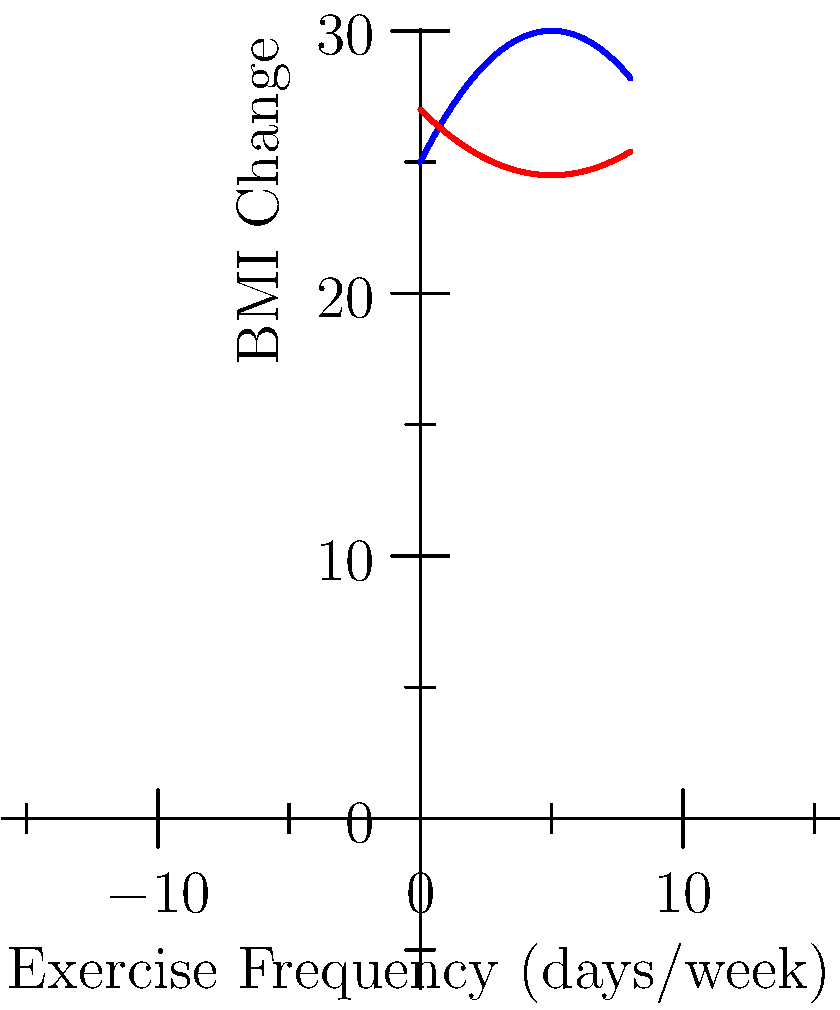The graph shows the relationship between exercise frequency and BMI change for two groups in a weight management study. Group A is represented by the blue curve (concave down) and Group B by the red curve (concave up). At what exercise frequency (in days per week) do both groups experience the same BMI change? Round your answer to one decimal place. To find the point where both groups experience the same BMI change, we need to find the intersection of the two polynomial functions:

1) Let's define the functions:
   Group A: $f(x) = -0.2x^2 + 2x + 25$
   Group B: $g(x) = 0.1x^2 - x + 27$

2) At the intersection point, $f(x) = g(x)$. So we set up the equation:
   $-0.2x^2 + 2x + 25 = 0.1x^2 - x + 27$

3) Rearrange the equation:
   $-0.3x^2 + 3x - 2 = 0$

4) This is a quadratic equation. We can solve it using the quadratic formula:
   $x = \frac{-b \pm \sqrt{b^2 - 4ac}}{2a}$

   Where $a = -0.3$, $b = 3$, and $c = -2$

5) Plugging in these values:
   $x = \frac{-3 \pm \sqrt{3^2 - 4(-0.3)(-2)}}{2(-0.3)}$

6) Simplifying:
   $x = \frac{-3 \pm \sqrt{9 - 2.4}}{-0.6} = \frac{-3 \pm \sqrt{6.6}}{-0.6}$

7) Calculating:
   $x \approx 5.4$ or $x \approx 1.8$

8) Looking at the graph, we can see that the intersection point is closer to 5, so we choose 5.4.

Therefore, both groups experience the same BMI change at an exercise frequency of approximately 5.4 days per week.
Answer: 5.4 days/week 